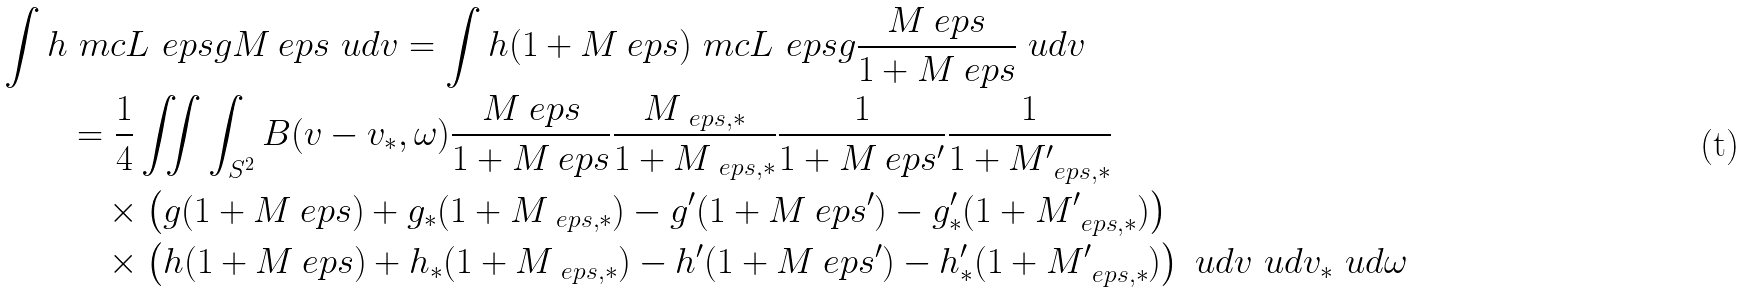Convert formula to latex. <formula><loc_0><loc_0><loc_500><loc_500>\int h & \ m c L _ { \ } e p s g M _ { \ } e p s \ u d v = \int h ( 1 + M _ { \ } e p s ) \ m c L _ { \ } e p s g \frac { M _ { \ } e p s } { 1 + M _ { \ } e p s } \ u d v \\ & = \frac { 1 } { 4 } \iint \int _ { S ^ { 2 } } B ( v - v _ { * } , \omega ) \frac { M _ { \ } e p s } { 1 + M _ { \ } e p s } \frac { M _ { \ e p s , * } } { 1 + M _ { \ e p s , * } } \frac { 1 } { 1 + M _ { \ } e p s ^ { \prime } } \frac { 1 } { 1 + M _ { \ e p s , * } ^ { \prime } } \\ & \quad \times \left ( g ( 1 + M _ { \ } e p s ) + g _ { * } ( 1 + M _ { \ e p s , * } ) - g ^ { \prime } ( 1 + M _ { \ } e p s ^ { \prime } ) - g _ { * } ^ { \prime } ( 1 + M _ { \ e p s , * } ^ { \prime } ) \right ) \\ & \quad \times \left ( h ( 1 + M _ { \ } e p s ) + h _ { * } ( 1 + M _ { \ e p s , * } ) - h ^ { \prime } ( 1 + M _ { \ } e p s ^ { \prime } ) - h _ { * } ^ { \prime } ( 1 + M _ { \ e p s , * } ^ { \prime } ) \right ) \ u d v \ u d v _ { * } \ u d \omega</formula> 